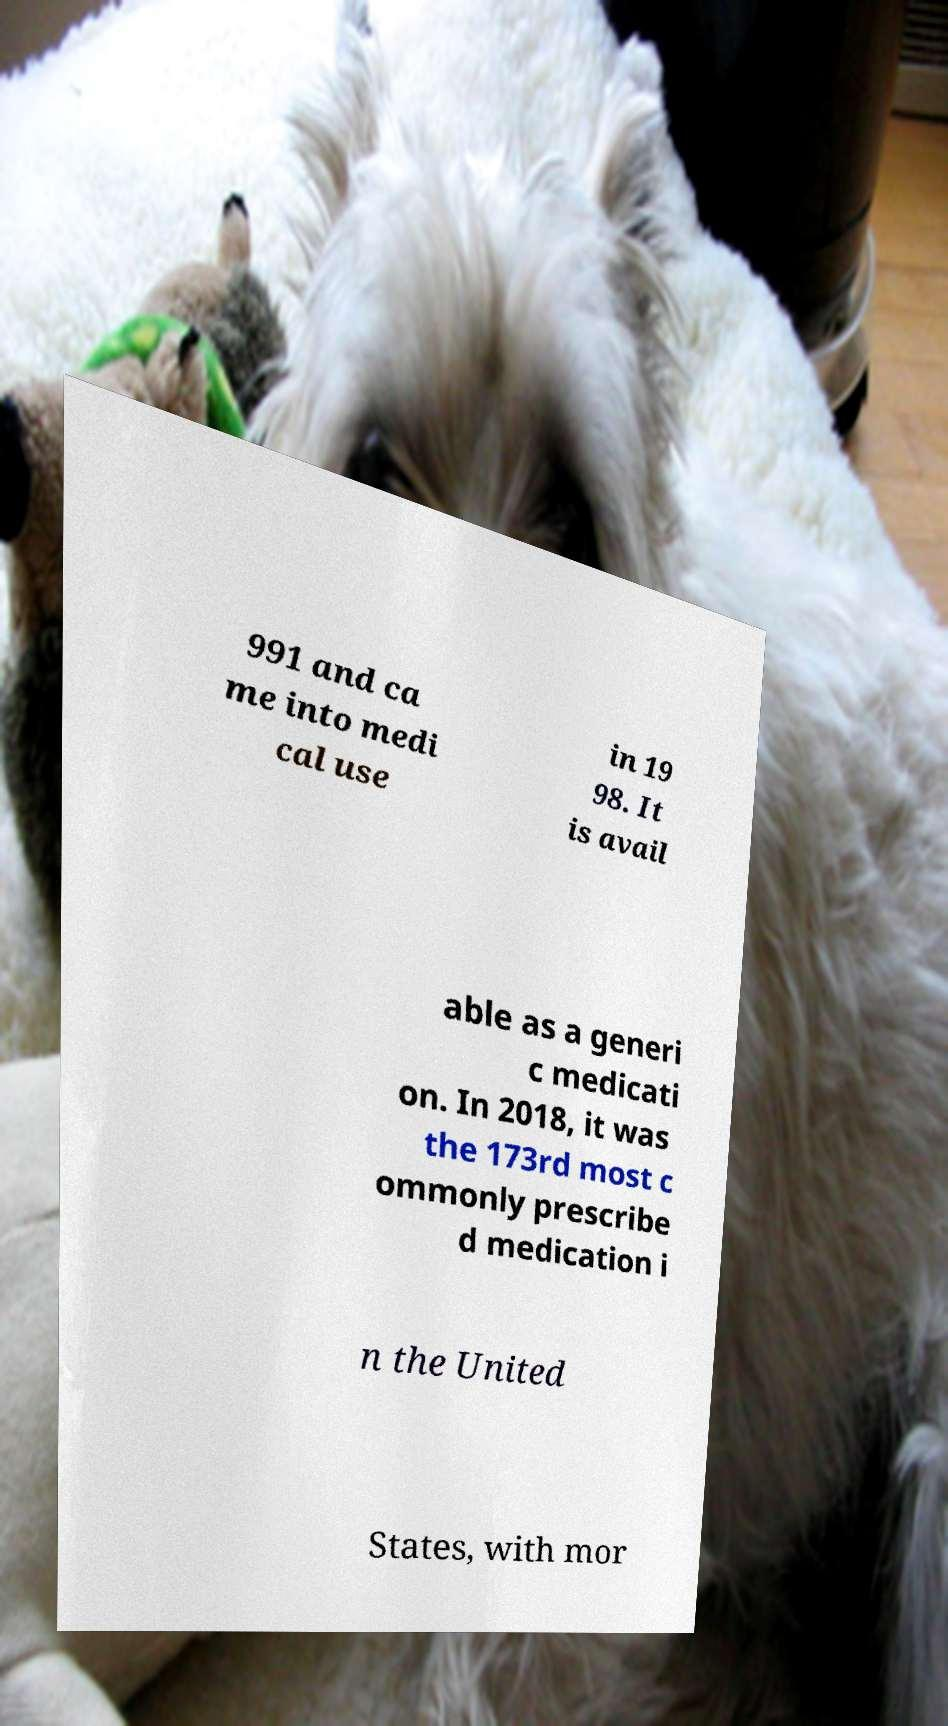There's text embedded in this image that I need extracted. Can you transcribe it verbatim? 991 and ca me into medi cal use in 19 98. It is avail able as a generi c medicati on. In 2018, it was the 173rd most c ommonly prescribe d medication i n the United States, with mor 